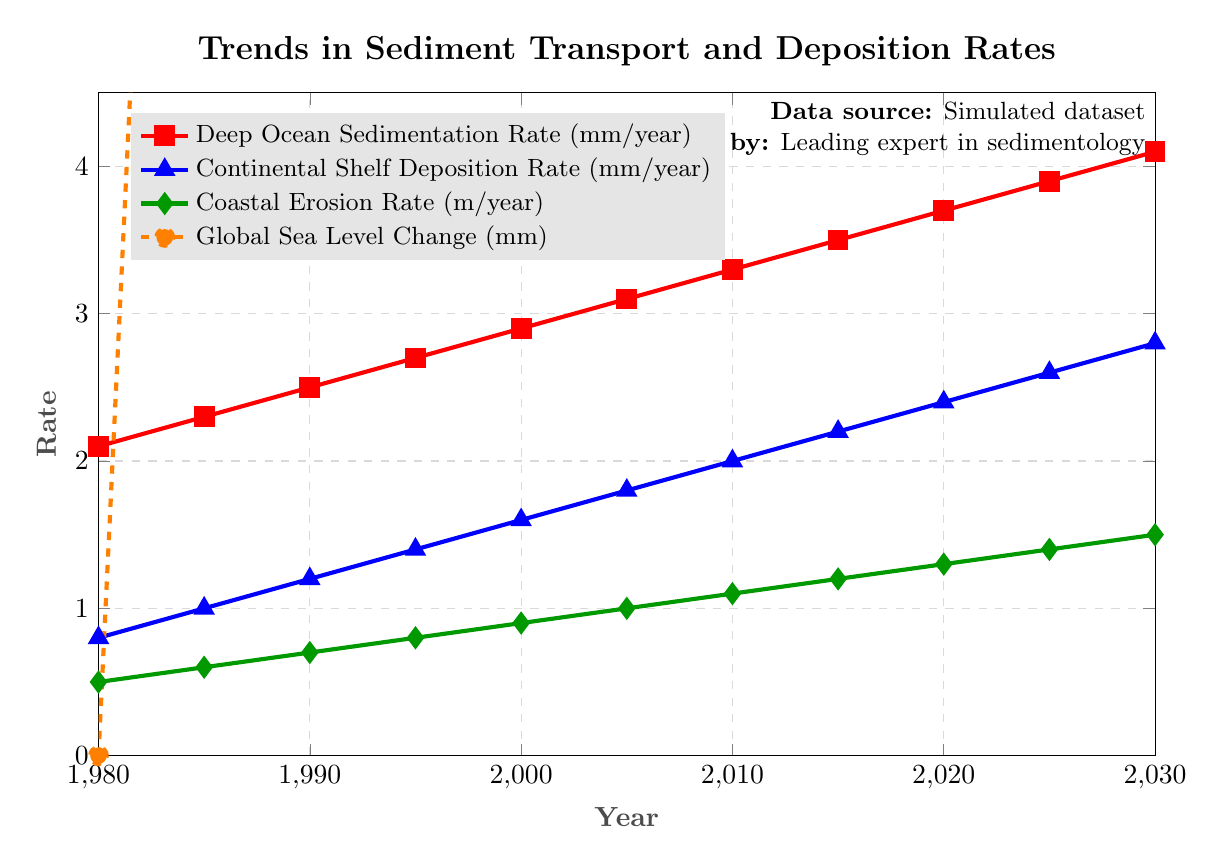What is the Deep Ocean Sedimentation Rate in 2010? Refer to the point in the red line labeled "Deep Ocean Sedimentation Rate (mm/year)" for the year 2010. The value is at the vertical coordinate corresponding to 3.3 mm/year.
Answer: 3.3 mm/year Which rate has seen the most dramatic increase from 1980 to 2030? Compare the increments of the three rates and the global sea level change between 1980 to 2030. The global sea level change has increased from 0 mm to 150 mm, showing the largest increase.
Answer: Global Sea Level Change Between which two years did the Coastal Erosion Rate increase by the same amount as the increase in Continental Shelf Deposition Rate between 1985 and 1990? The increase in Coastal Erosion Rate between 1985 and 1990 is from 0.6 to 0.7, an increase of 0.1. Find other pairs of years for the Coastal Erosion Rate with the same increase. The Coastal Erosion Rate between 2005 and 2010 also increased by 0.1 (from 1.0 to 1.1).
Answer: 2005-2010 What was the Deep Ocean Sedimentation Rate in the year when the Continental Shelf Deposition Rate was 2.2 mm/year? Locate the year when the Continental Shelf Deposition Rate is 2.2 mm/year (2015) and then find the corresponding value on the red line for the Deep Ocean Sedimentation Rate. The value is 3.5 mm/year in 2015.
Answer: 3.5 mm/year By what amount did the Global Sea Level Change increase from 2000 to 2010? Subtract the Global Sea Level Change in 2000 from the value in 2010 as per the orange line: 90 mm - 60 mm = 30 mm.
Answer: 30 mm What year corresponds to a Continental Shelf Deposition Rate of 1.8 mm/year? Refer to the blue line labeled "Continental Shelf Deposition Rate (mm/year)" and locate the point where the value is 1.8 mm/year. This corresponds to the year 2005.
Answer: 2005 How much higher is the Deep Ocean Sedimentation Rate compared to the Coastal Erosion Rate in 2020? Find the corresponding values for the year 2020 on the red and green lines. Deep Ocean Sedimentation Rate is 3.7 mm/year, and Coastal Erosion Rate is 1.3 m/year. The difference is 3.7 - 1.3 = 2.4.
Answer: 2.4 mm/year Compare the rate of increase in the Coastal Erosion Rate to the Deep Ocean Sedimentation Rate from 1980 to 2020. Which one has a steeper increase? Calculate the difference in values from 1980 to 2020 for both rates. Coastal Erosion Rate increases from 0.5 to 1.3 (an increase of 0.8) and Deep Ocean Sedimentation Rate increases from 2.1 to 3.7 (an increase of 1.6). The Deep Ocean Sedimentation Rate has a steeper increase.
Answer: Deep Ocean Sedimentation Rate 